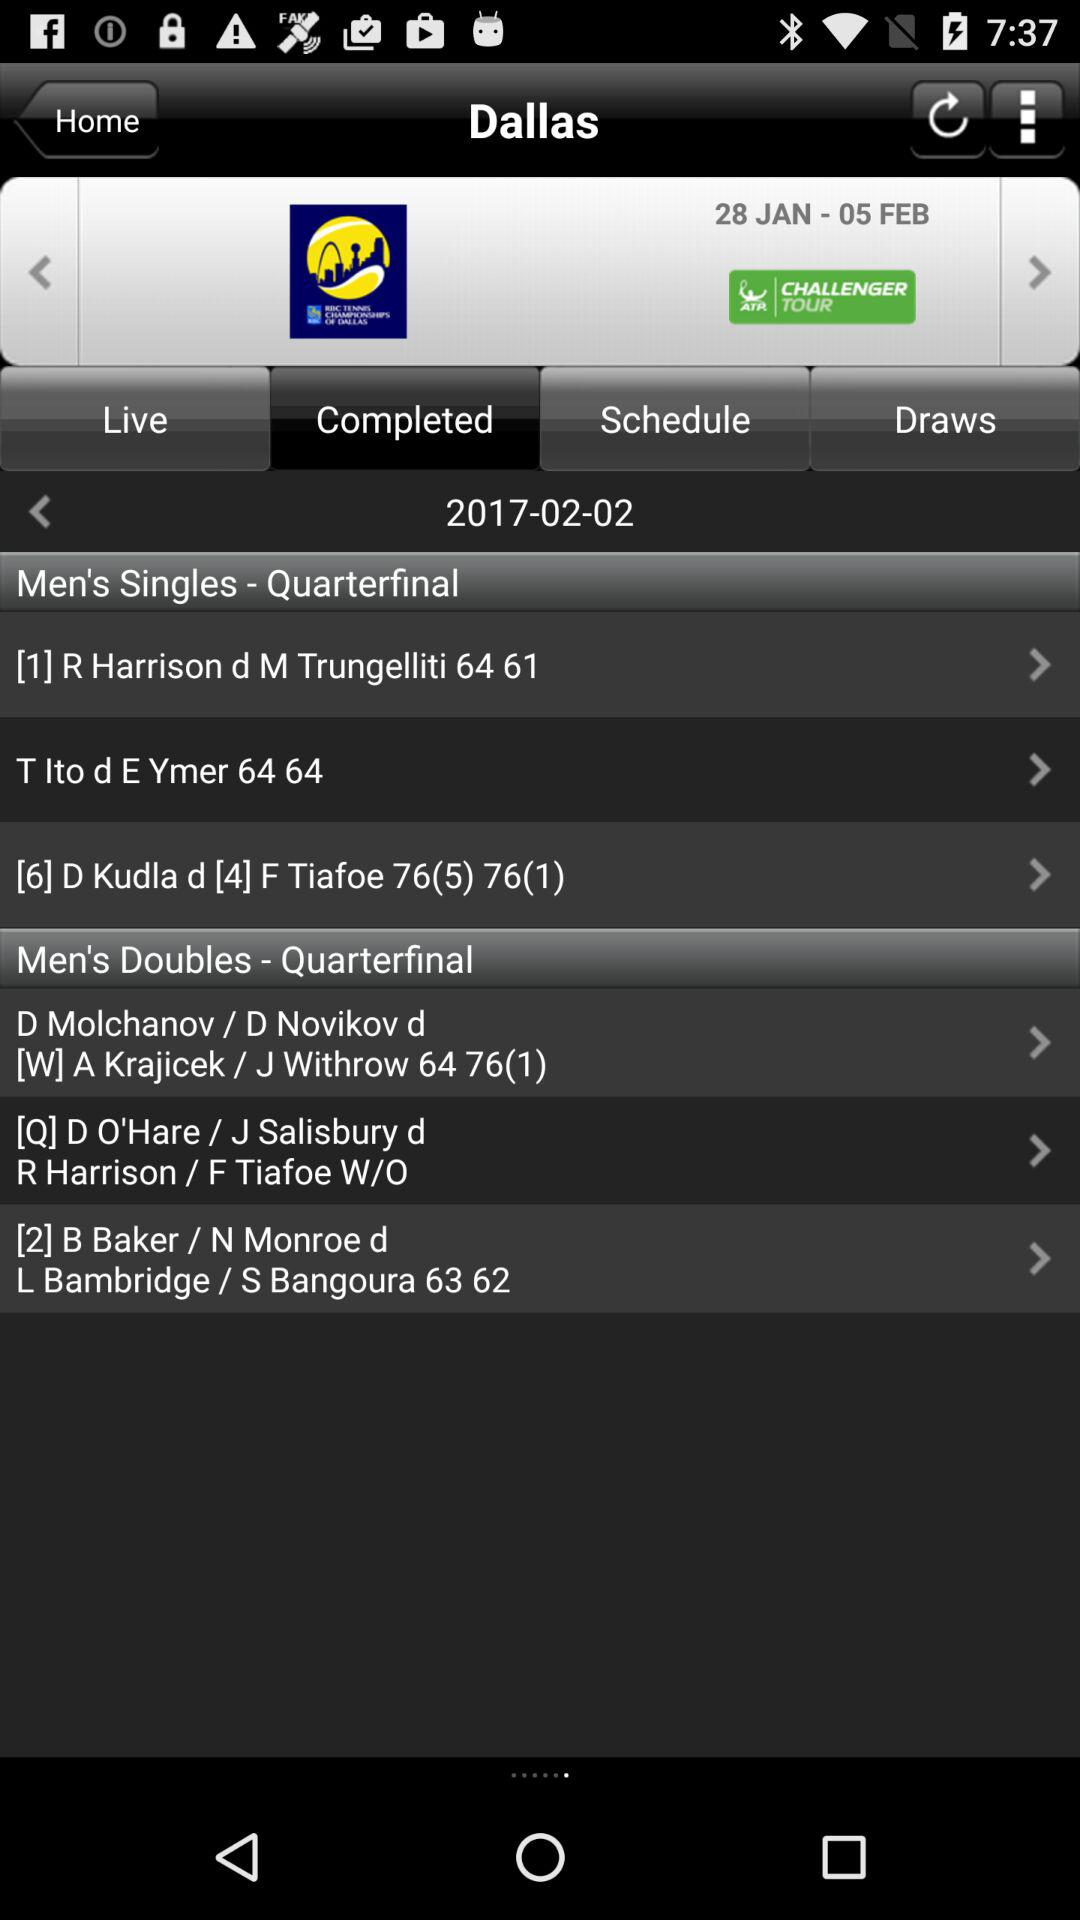On which date was the "Men's Singles - Quarterfinal" held? The "Men's Singles - Quarterfinal" was held on February 2, 2017. 